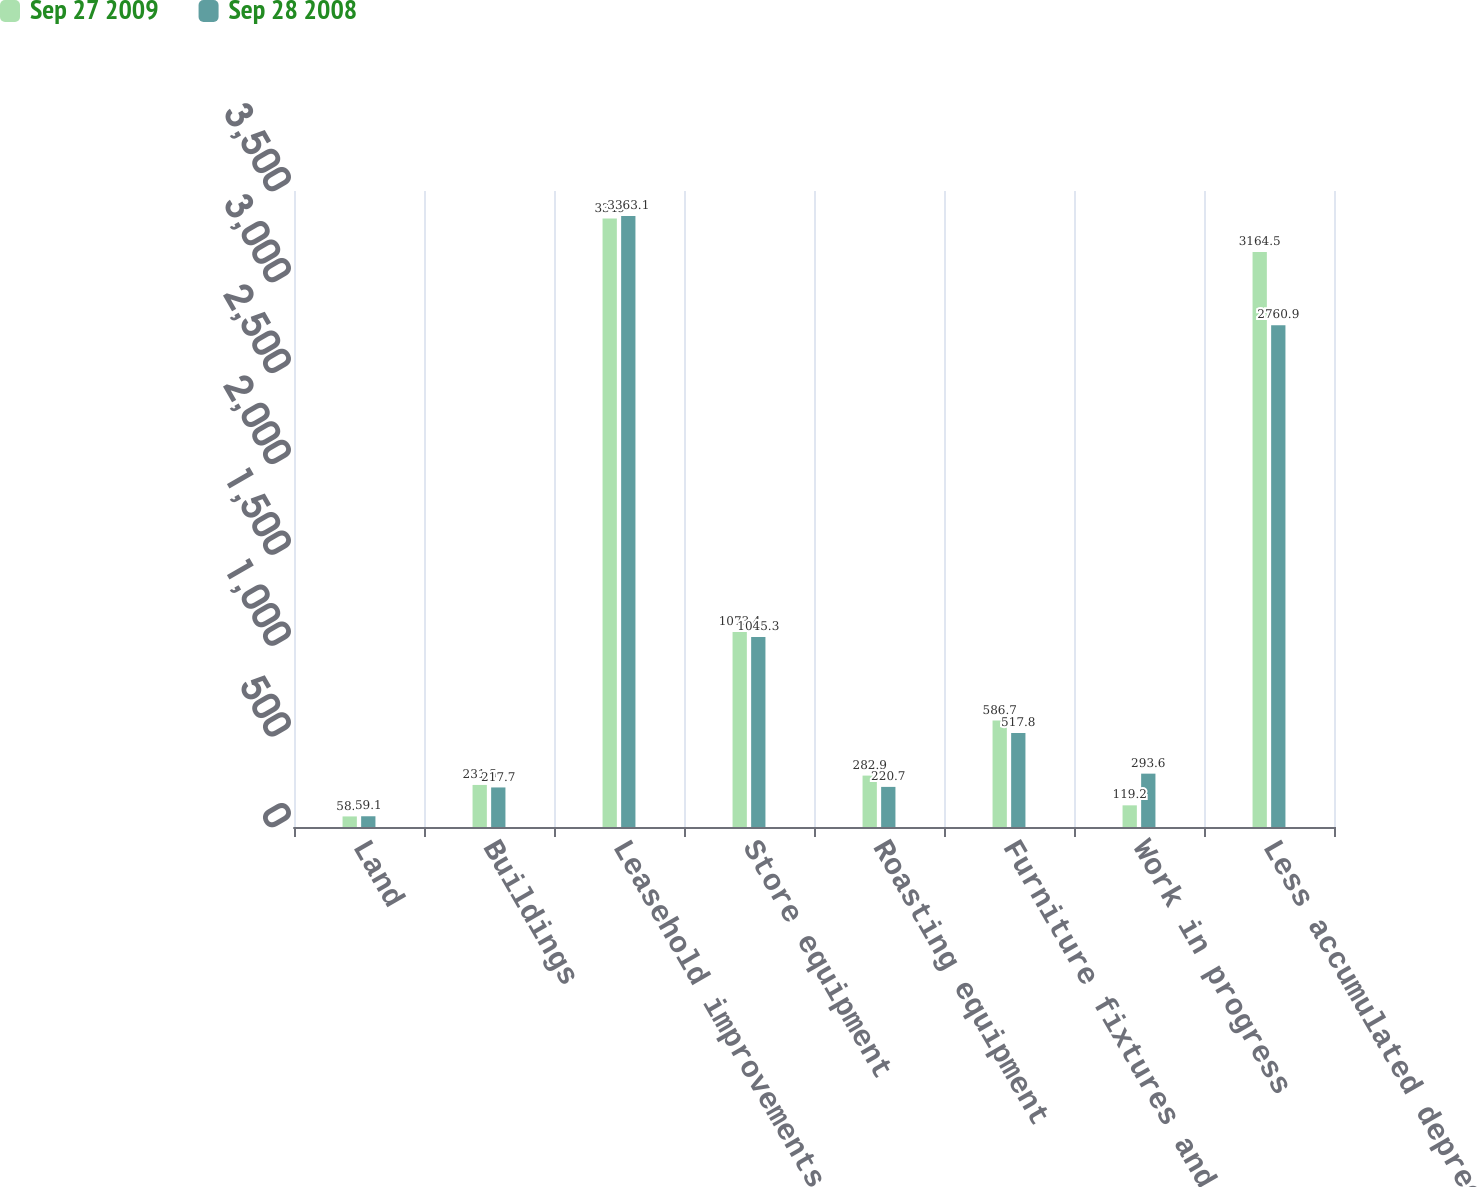<chart> <loc_0><loc_0><loc_500><loc_500><stacked_bar_chart><ecel><fcel>Land<fcel>Buildings<fcel>Leasehold improvements<fcel>Store equipment<fcel>Roasting equipment<fcel>Furniture fixtures and other<fcel>Work in progress<fcel>Less accumulated depreciation<nl><fcel>Sep 27 2009<fcel>58.2<fcel>231.5<fcel>3349<fcel>1073.4<fcel>282.9<fcel>586.7<fcel>119.2<fcel>3164.5<nl><fcel>Sep 28 2008<fcel>59.1<fcel>217.7<fcel>3363.1<fcel>1045.3<fcel>220.7<fcel>517.8<fcel>293.6<fcel>2760.9<nl></chart> 